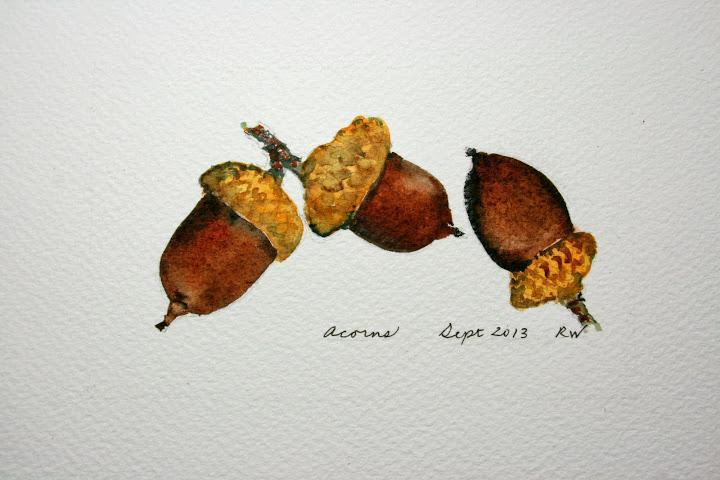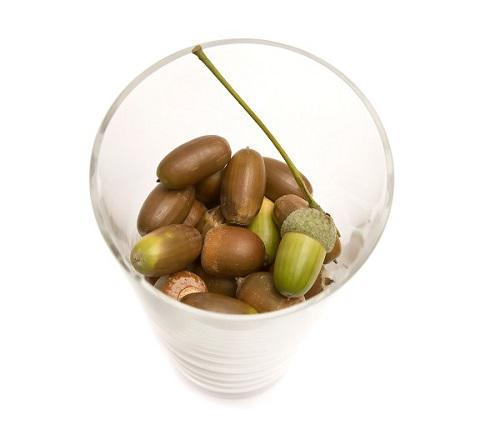The first image is the image on the left, the second image is the image on the right. For the images shown, is this caption "The left image contains exactly three brown acorns with their caps on." true? Answer yes or no. Yes. 